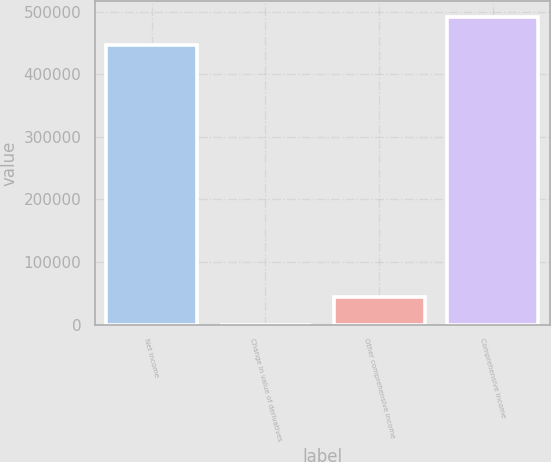<chart> <loc_0><loc_0><loc_500><loc_500><bar_chart><fcel>Net income<fcel>Change in value of derivatives<fcel>Other comprehensive income<fcel>Comprehensive income<nl><fcel>447221<fcel>81<fcel>44803.1<fcel>491943<nl></chart> 